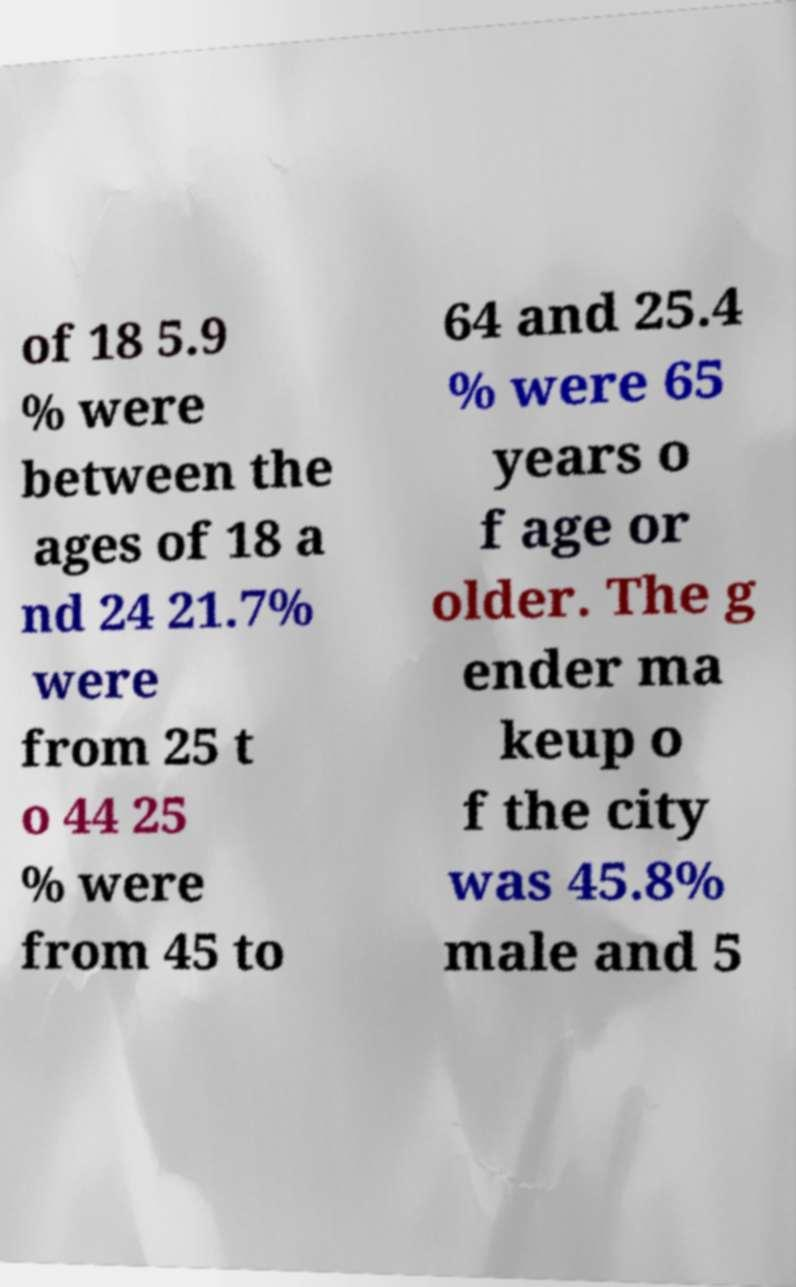Please read and relay the text visible in this image. What does it say? of 18 5.9 % were between the ages of 18 a nd 24 21.7% were from 25 t o 44 25 % were from 45 to 64 and 25.4 % were 65 years o f age or older. The g ender ma keup o f the city was 45.8% male and 5 